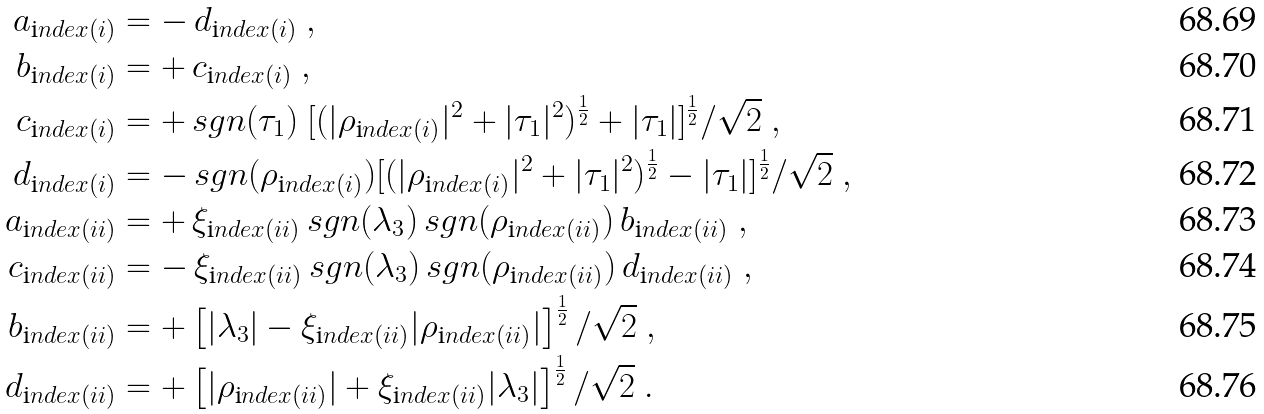Convert formula to latex. <formula><loc_0><loc_0><loc_500><loc_500>a _ { \text  index{(i)} } & = - \, d _ { \text  index{(i)} } \ , \\ b _ { \text  index{(i)} } & = + \, c _ { \text  index{(i)} } \ , \\ c _ { \text  index{(i)} } & = + \, s g n ( \tau _ { 1 } ) \ [ ( | \rho _ { \text  index{(i)} } | ^ { 2 } + | \tau _ { 1 } | ^ { 2 } ) ^ { \frac { 1 } { 2 } } + | \tau _ { 1 } | ] ^ { \frac { 1 } { 2 } } / \sqrt { 2 } \ , \\ d _ { \text  index{(i)} } & = - \, s g n ( \rho _ { \text  index{(i)} } ) [ ( | \rho _ { \text  index{(i)} } | ^ { 2 } + | \tau _ { 1 } | ^ { 2 } ) ^ { \frac { 1 } { 2 } } - | \tau _ { 1 } | ] ^ { \frac { 1 } { 2 } } / \sqrt { 2 } \ , \\ a _ { \text  index{(ii)} } & = + \, \xi _ { \text  index{(ii)} } \, s g n ( \lambda _ { 3 } ) \, s g n ( \rho _ { \text  index{(ii)} } ) \, b _ { \text  index{(ii)} } \ , \\ c _ { \text  index{(ii)} } & = - \, \xi _ { \text  index{(ii)} } \, s g n ( \lambda _ { 3 } ) \, s g n ( \rho _ { \text  index{(ii)} } ) \, d _ { \text  index{(ii)} } \ , \\ b _ { \text  index{(ii)} } & = + \left [ | \lambda _ { 3 } | - \xi _ { \text  index{(ii)} } | \rho _ { \text  index{(ii)} } | \right ] ^ { \frac { 1 } { 2 } } / \sqrt { 2 } \ , \\ d _ { \text  index{(ii)} } & = + \left [ | \rho _ { \text  index{(ii)} } | + \xi _ { \text  index{(ii)} } | \lambda _ { 3 } | \right ] ^ { \frac { 1 } { 2 } } / \sqrt { 2 } \ .</formula> 